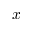<formula> <loc_0><loc_0><loc_500><loc_500>x</formula> 